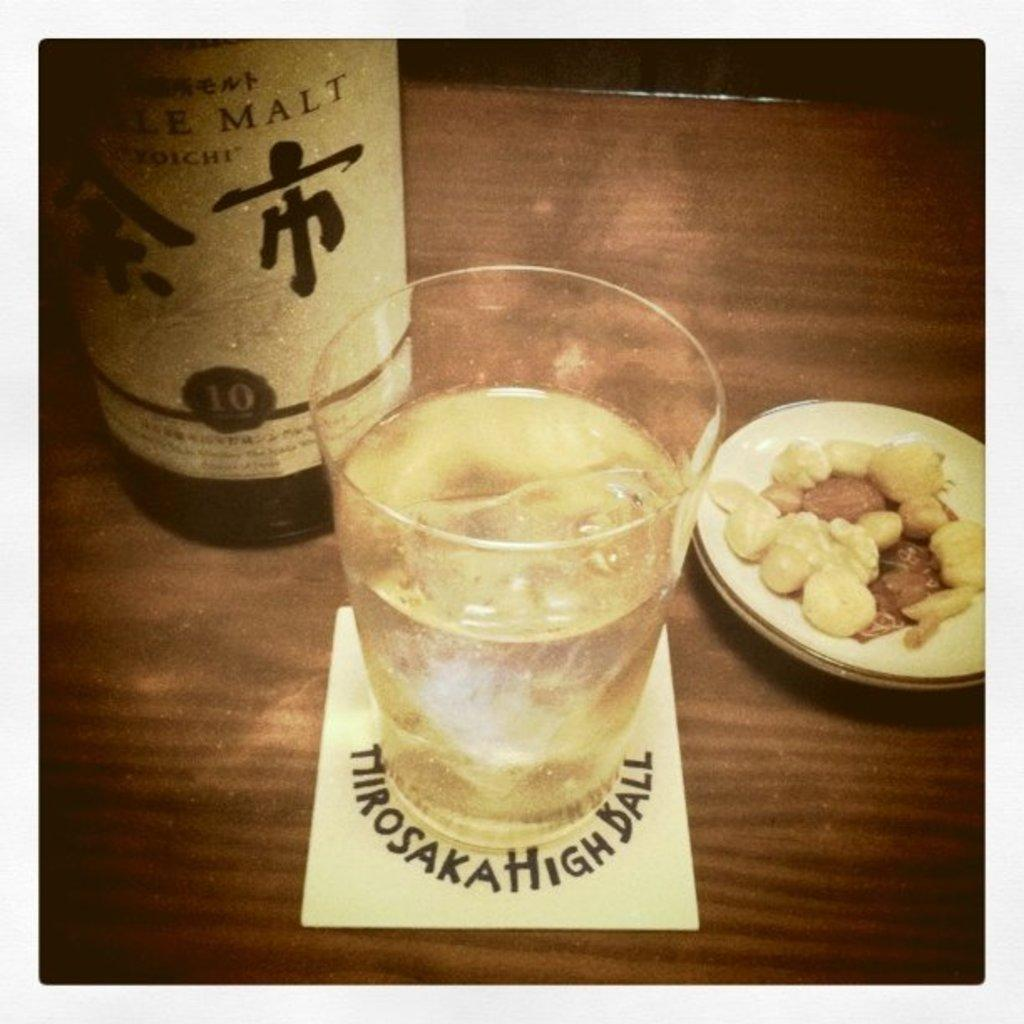Provide a one-sentence caption for the provided image. A bottle of wine and a glass sitting on coaster reading tiirosaka high ball. 